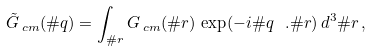<formula> <loc_0><loc_0><loc_500><loc_500>{ \tilde { G } } _ { \, c m } ( \# q ) = \int _ { \# r } G _ { \, c m } ( \# r ) \, \exp ( - i \# q \ . \# r ) \, d ^ { 3 } \# r \, ,</formula> 